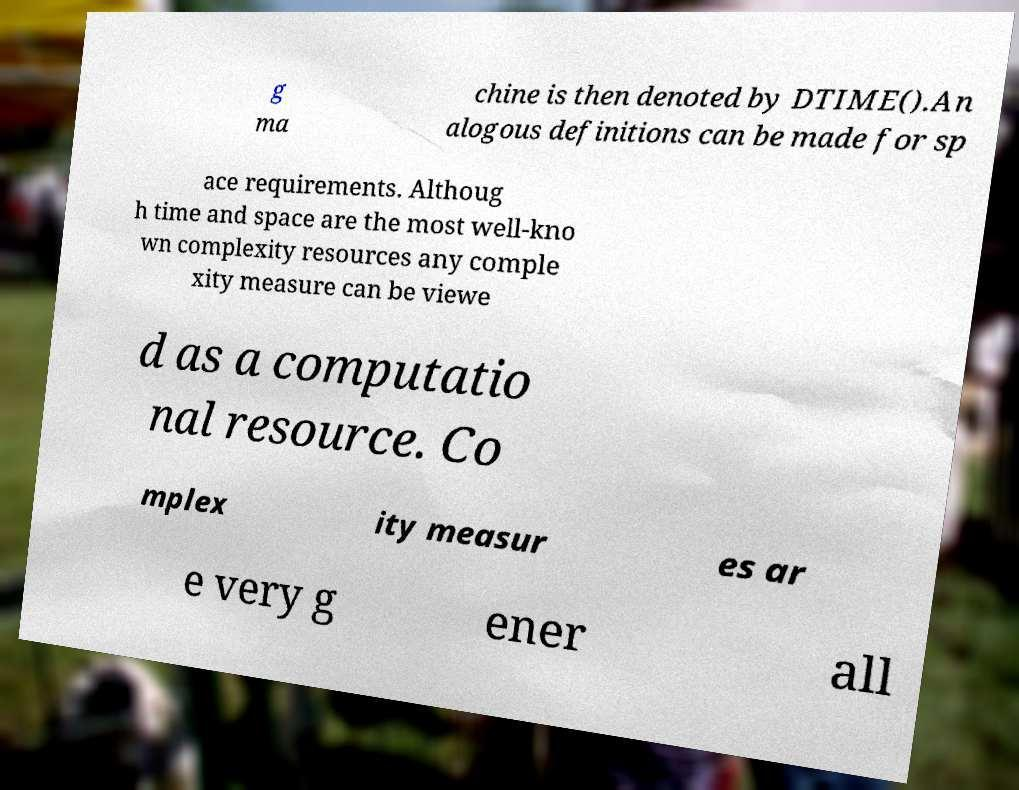For documentation purposes, I need the text within this image transcribed. Could you provide that? g ma chine is then denoted by DTIME().An alogous definitions can be made for sp ace requirements. Althoug h time and space are the most well-kno wn complexity resources any comple xity measure can be viewe d as a computatio nal resource. Co mplex ity measur es ar e very g ener all 